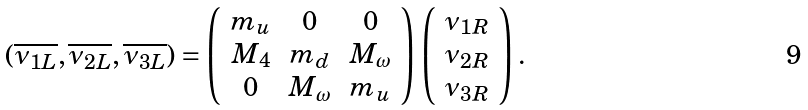Convert formula to latex. <formula><loc_0><loc_0><loc_500><loc_500>( \overline { \nu _ { 1 L } } , \overline { \nu _ { 2 L } } , \overline { \nu _ { 3 L } } ) = \left ( \begin{array} { c c c } m _ { u } & 0 & 0 \\ M _ { 4 } & m _ { d } & M _ { \omega } \\ 0 & M _ { \omega } & m _ { u } \\ \end{array} \right ) \left ( \begin{array} { c } \nu _ { 1 R } \\ \nu _ { 2 R } \\ \nu _ { 3 R } \\ \end{array} \right ) .</formula> 